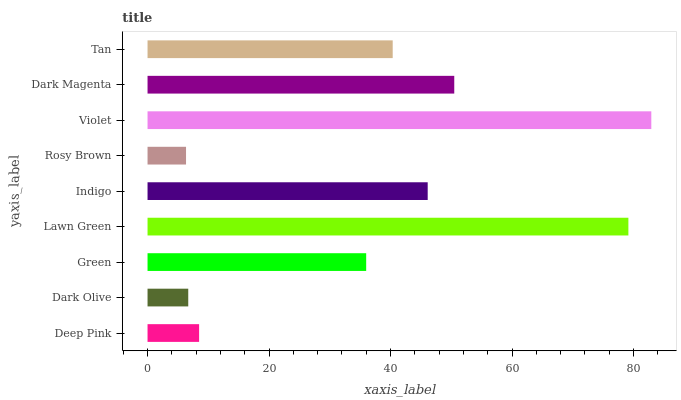Is Rosy Brown the minimum?
Answer yes or no. Yes. Is Violet the maximum?
Answer yes or no. Yes. Is Dark Olive the minimum?
Answer yes or no. No. Is Dark Olive the maximum?
Answer yes or no. No. Is Deep Pink greater than Dark Olive?
Answer yes or no. Yes. Is Dark Olive less than Deep Pink?
Answer yes or no. Yes. Is Dark Olive greater than Deep Pink?
Answer yes or no. No. Is Deep Pink less than Dark Olive?
Answer yes or no. No. Is Tan the high median?
Answer yes or no. Yes. Is Tan the low median?
Answer yes or no. Yes. Is Green the high median?
Answer yes or no. No. Is Deep Pink the low median?
Answer yes or no. No. 